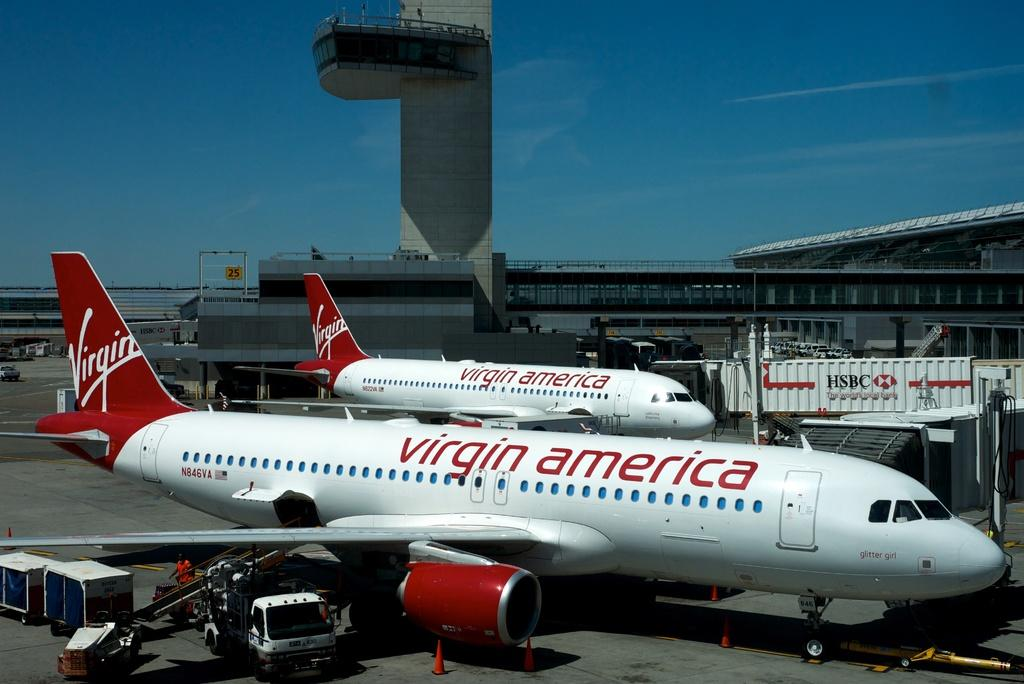Provide a one-sentence caption for the provided image. Two virgin American planes side by side on the tarmac. 